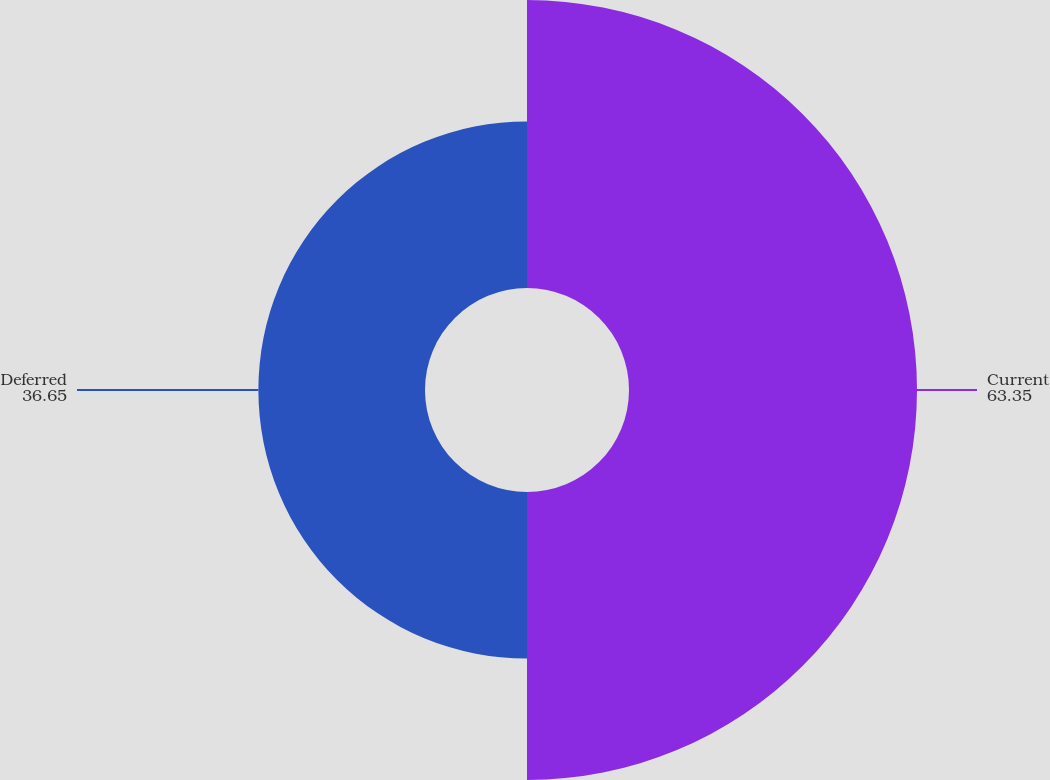Convert chart to OTSL. <chart><loc_0><loc_0><loc_500><loc_500><pie_chart><fcel>Current<fcel>Deferred<nl><fcel>63.35%<fcel>36.65%<nl></chart> 